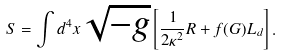<formula> <loc_0><loc_0><loc_500><loc_500>S = \int d ^ { 4 } x \sqrt { - g } \left [ \frac { 1 } { 2 \kappa ^ { 2 } } R + f ( G ) L _ { d } \right ] .</formula> 